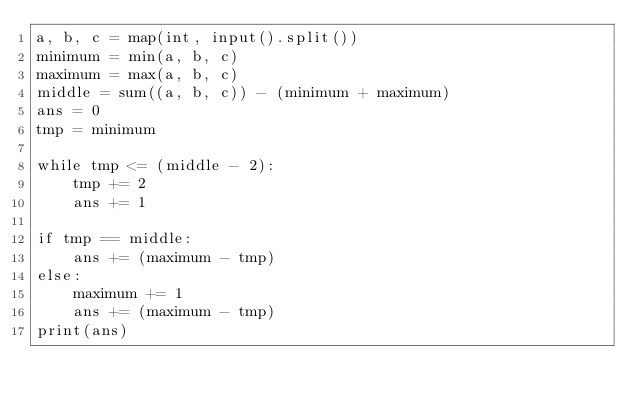<code> <loc_0><loc_0><loc_500><loc_500><_Python_>a, b, c = map(int, input().split())
minimum = min(a, b, c)
maximum = max(a, b, c)
middle = sum((a, b, c)) - (minimum + maximum)
ans = 0
tmp = minimum

while tmp <= (middle - 2):
    tmp += 2
    ans += 1

if tmp == middle:
    ans += (maximum - tmp)
else:
    maximum += 1
    ans += (maximum - tmp)
print(ans)
</code> 